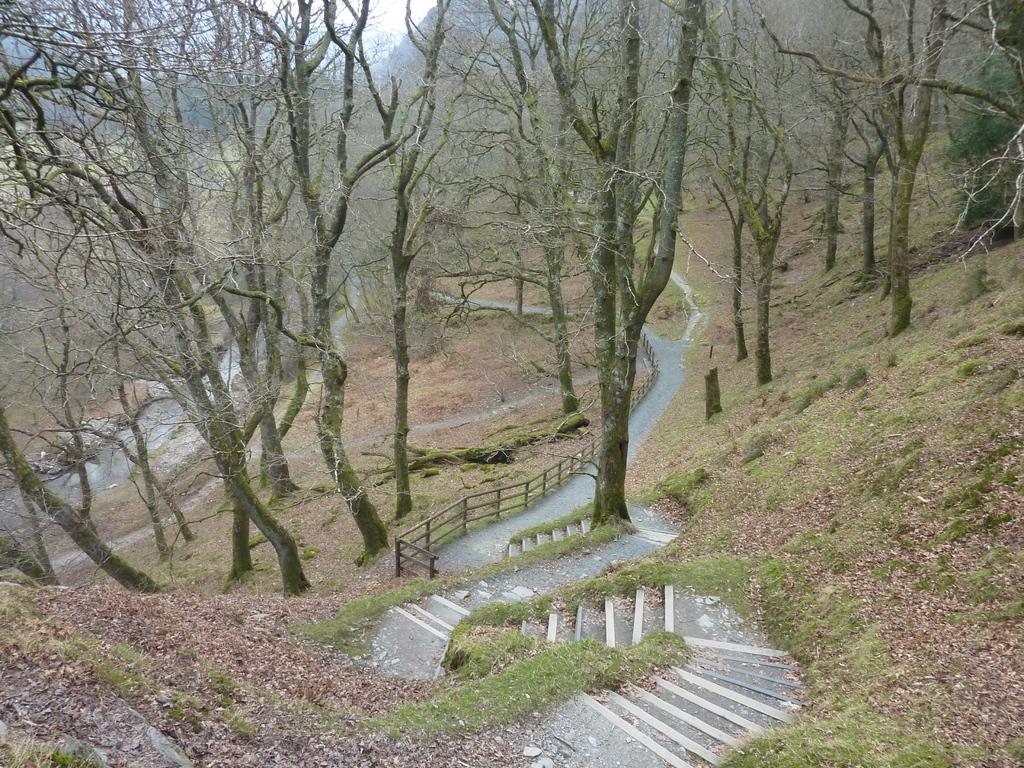Describe this image in one or two sentences. In this image there are few stairs surrounded by the grass are on the land. There is a path, beside there is fence. There are few trees on the land, behind there are hills and sky. 